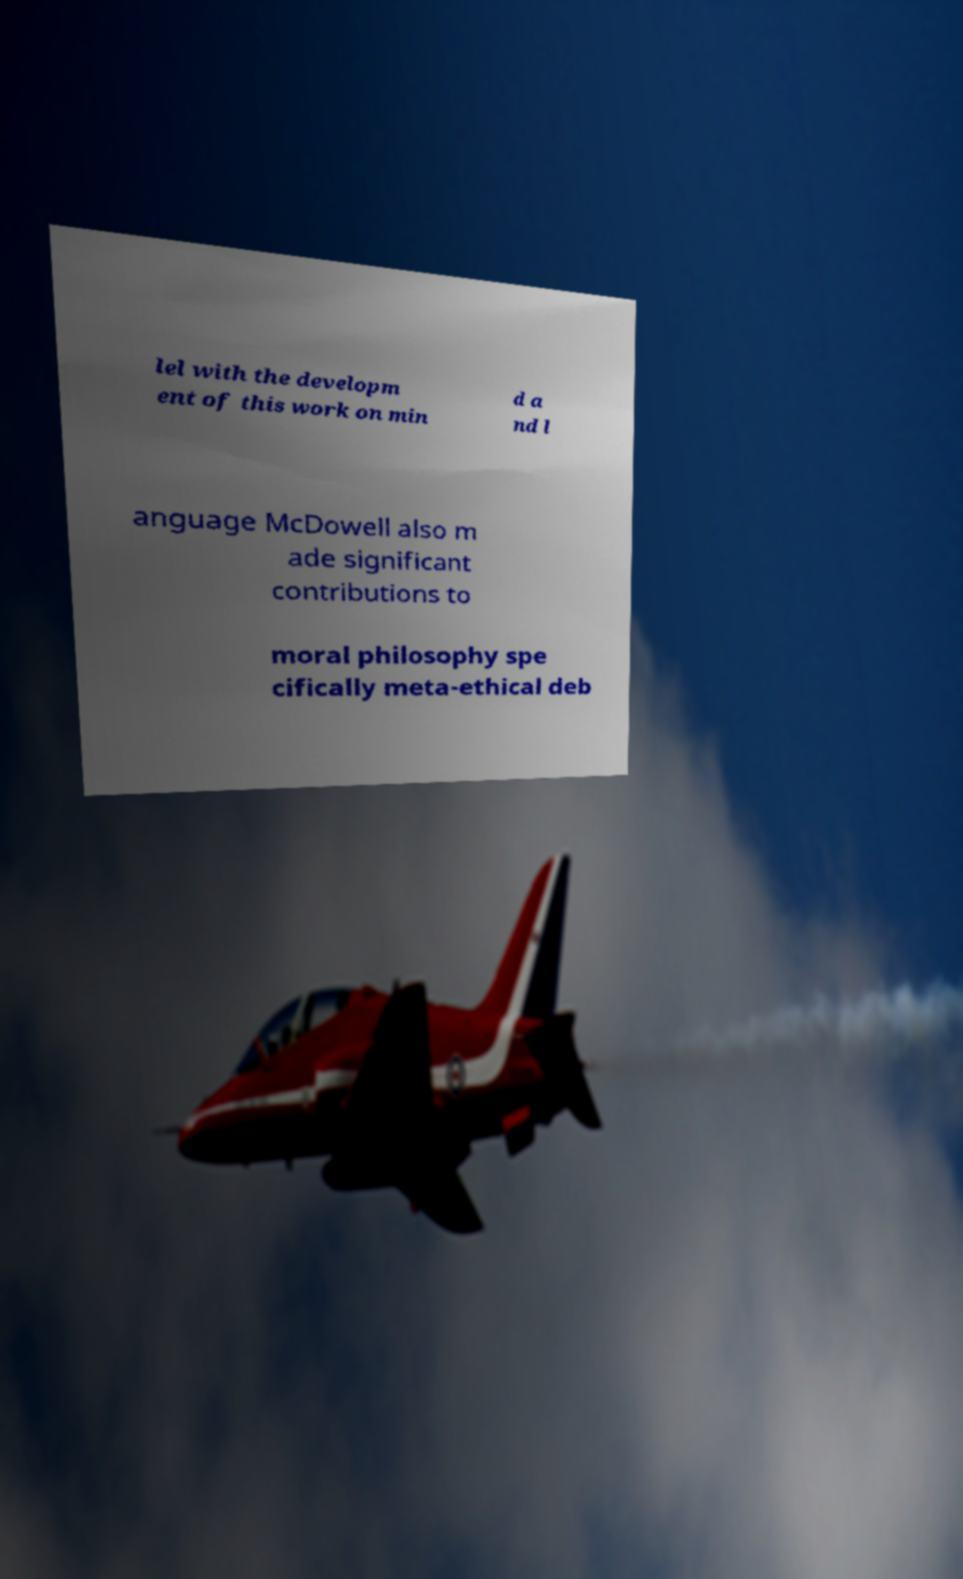I need the written content from this picture converted into text. Can you do that? lel with the developm ent of this work on min d a nd l anguage McDowell also m ade significant contributions to moral philosophy spe cifically meta-ethical deb 